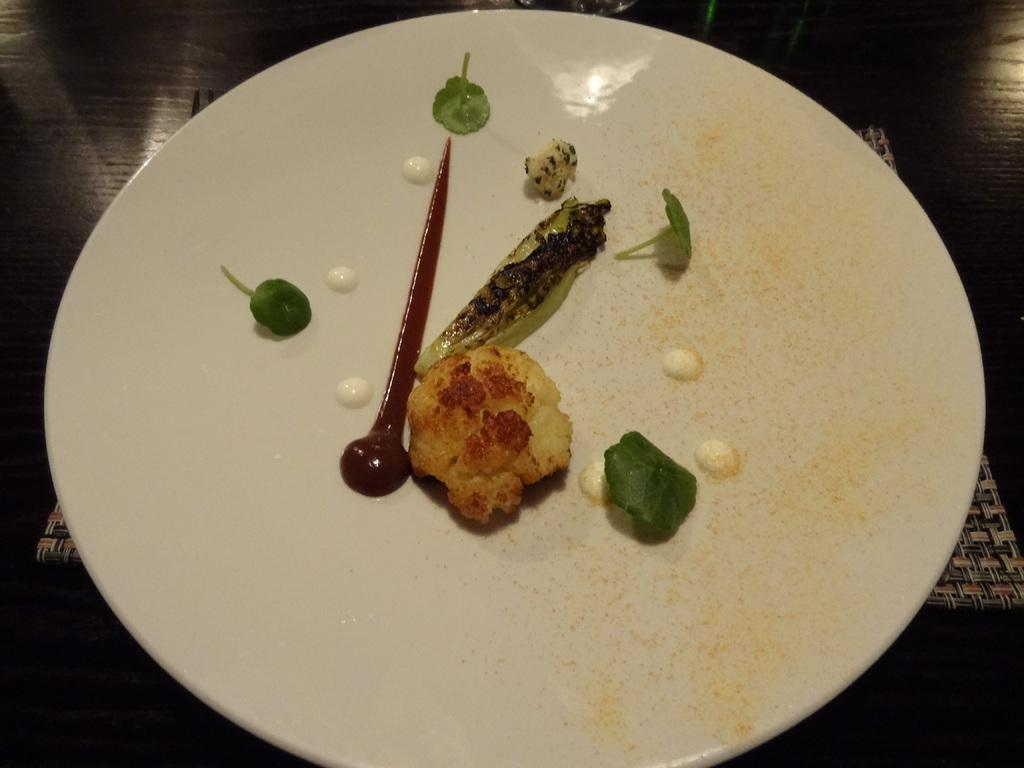What is present on the plate in the image? There are food items in a plate. Can you describe anything in the background of the image? There is an object in the background of the image. How would you describe the lighting in the background of the image? The background view is dark. How many times do the people in the image hope for a kiss? There are no people present in the image, and therefore no such interaction can be observed. 